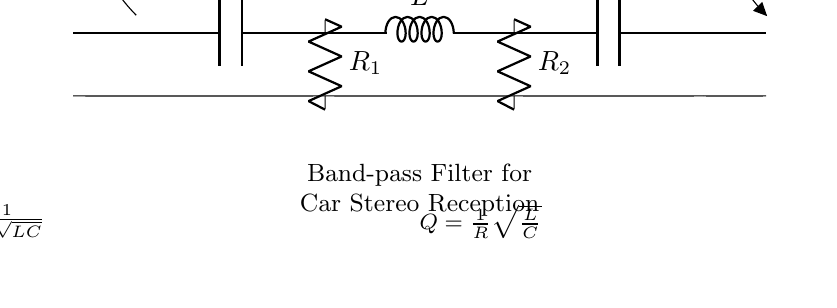What type of filter is shown in the circuit? The circuit is labeled as a band-pass filter, which allows frequencies within a certain range to pass while attenuating frequencies outside that range.
Answer: band-pass filter What components are used in the circuit? The circuit contains two capacitors (C1 and C2), one inductor (L), and two resistors (R1 and R2), as indicated by the labels next to each component in the diagram.
Answer: Capacitors, Inductor, Resistors What does the symbol Vout represent? The symbol Vout indicates the output voltage, which is the voltage measured across the terminals of the band-pass filter.
Answer: output voltage What is the formula provided for the cutoff frequency? The formula for the cutoff frequency (fc) is shown as fc = 1/(2π√(LC)), which relates the frequency at which the filter starts to attenuate signals.
Answer: fc = 1/(2π√(LC)) 